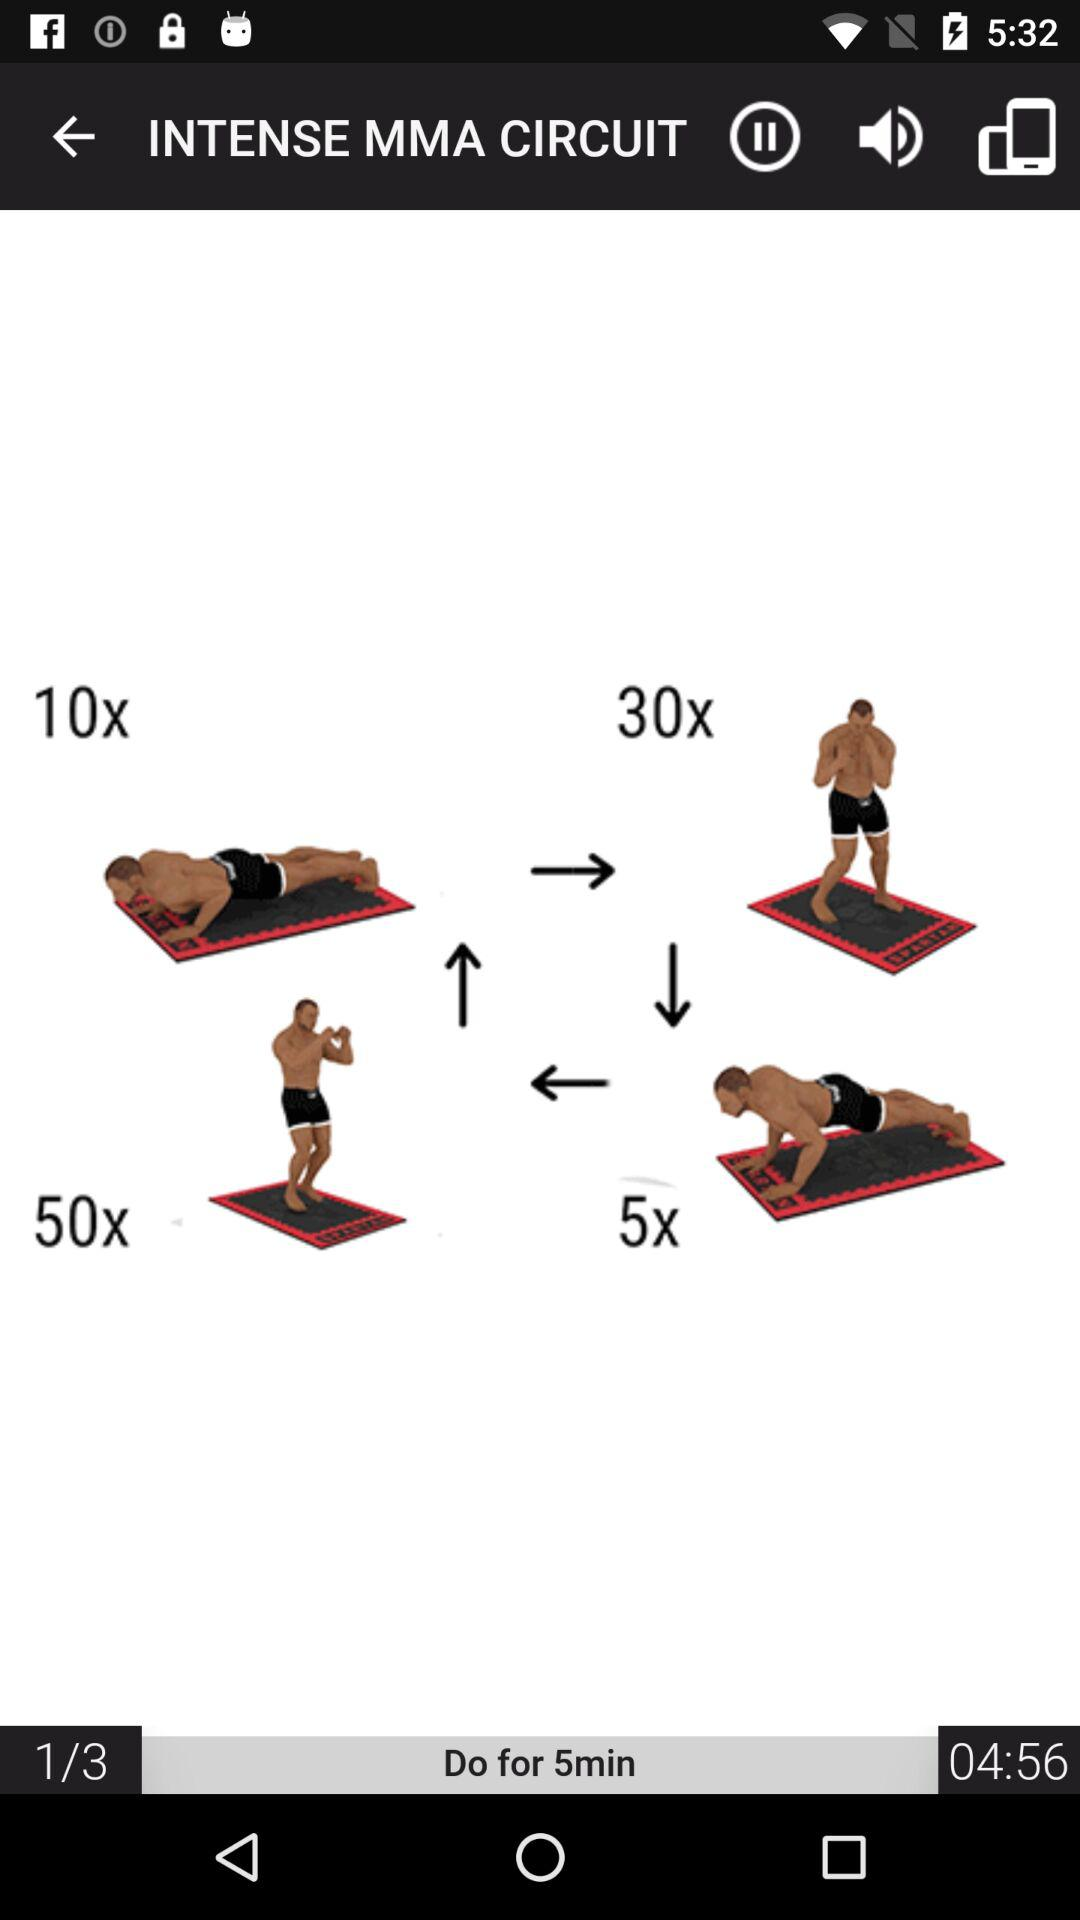Which number are we on? You are on number 1. 